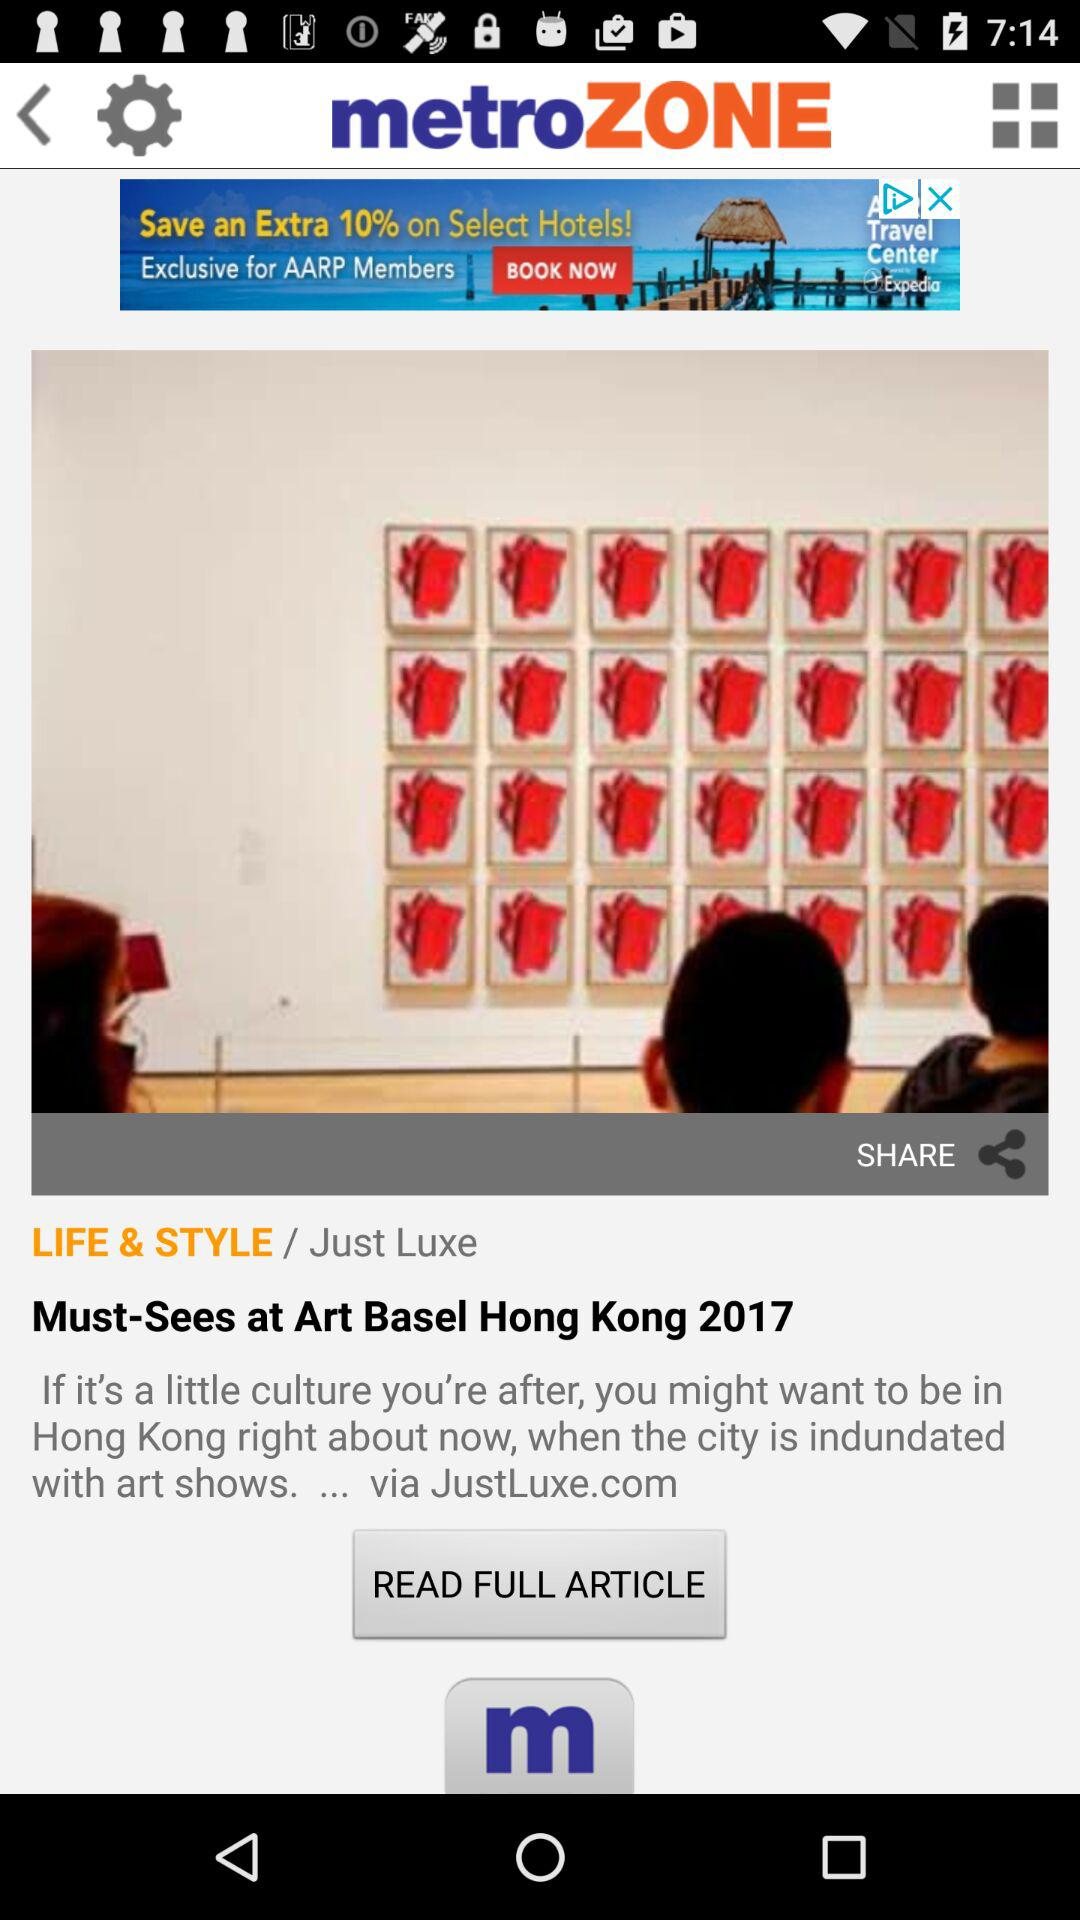What is the name of the application? The name of the application is "metroZONE". 